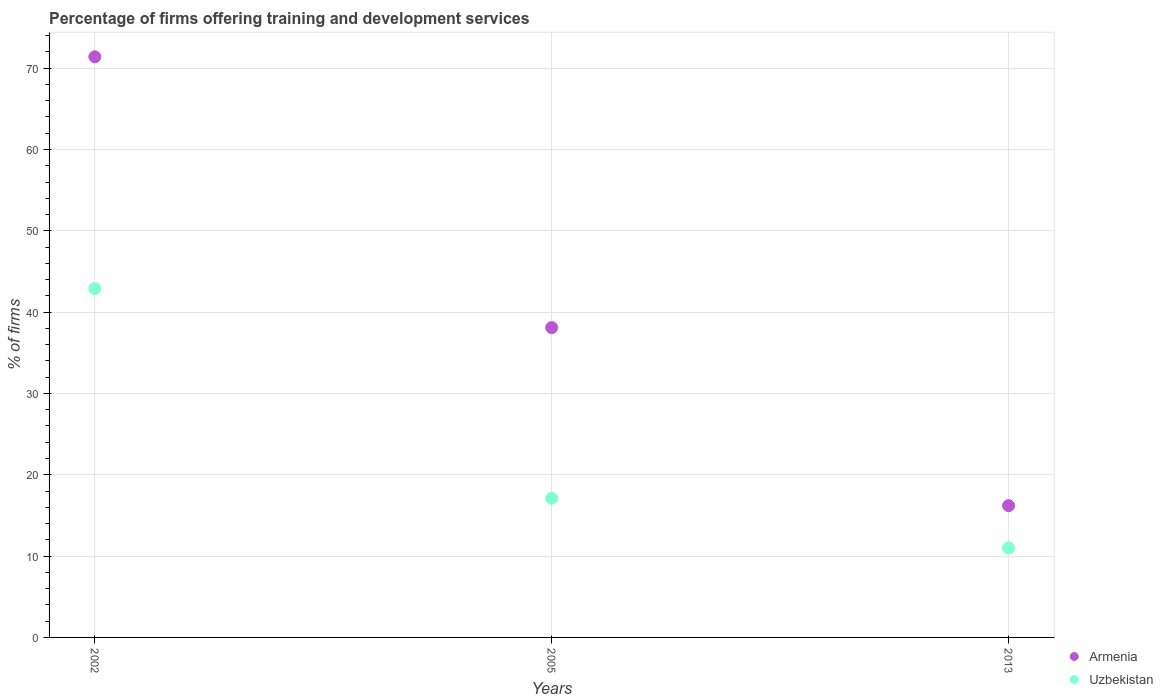How many different coloured dotlines are there?
Make the answer very short. 2. Is the number of dotlines equal to the number of legend labels?
Your answer should be very brief. Yes. What is the percentage of firms offering training and development in Armenia in 2005?
Give a very brief answer. 38.1. Across all years, what is the maximum percentage of firms offering training and development in Uzbekistan?
Make the answer very short. 42.9. Across all years, what is the minimum percentage of firms offering training and development in Uzbekistan?
Offer a very short reply. 11. In which year was the percentage of firms offering training and development in Uzbekistan minimum?
Make the answer very short. 2013. What is the total percentage of firms offering training and development in Armenia in the graph?
Provide a short and direct response. 125.7. What is the difference between the percentage of firms offering training and development in Armenia in 2002 and that in 2005?
Offer a terse response. 33.3. What is the difference between the percentage of firms offering training and development in Uzbekistan in 2002 and the percentage of firms offering training and development in Armenia in 2013?
Ensure brevity in your answer.  26.7. What is the average percentage of firms offering training and development in Uzbekistan per year?
Provide a succinct answer. 23.67. In the year 2005, what is the difference between the percentage of firms offering training and development in Armenia and percentage of firms offering training and development in Uzbekistan?
Make the answer very short. 21. In how many years, is the percentage of firms offering training and development in Armenia greater than 34 %?
Make the answer very short. 2. Is the percentage of firms offering training and development in Uzbekistan in 2002 less than that in 2005?
Your response must be concise. No. Is the difference between the percentage of firms offering training and development in Armenia in 2002 and 2013 greater than the difference between the percentage of firms offering training and development in Uzbekistan in 2002 and 2013?
Your answer should be very brief. Yes. What is the difference between the highest and the second highest percentage of firms offering training and development in Armenia?
Provide a short and direct response. 33.3. What is the difference between the highest and the lowest percentage of firms offering training and development in Armenia?
Give a very brief answer. 55.2. In how many years, is the percentage of firms offering training and development in Uzbekistan greater than the average percentage of firms offering training and development in Uzbekistan taken over all years?
Ensure brevity in your answer.  1. Does the percentage of firms offering training and development in Armenia monotonically increase over the years?
Offer a terse response. No. Is the percentage of firms offering training and development in Uzbekistan strictly less than the percentage of firms offering training and development in Armenia over the years?
Provide a succinct answer. Yes. How many dotlines are there?
Give a very brief answer. 2. What is the difference between two consecutive major ticks on the Y-axis?
Provide a succinct answer. 10. Are the values on the major ticks of Y-axis written in scientific E-notation?
Give a very brief answer. No. What is the title of the graph?
Your answer should be very brief. Percentage of firms offering training and development services. Does "El Salvador" appear as one of the legend labels in the graph?
Your response must be concise. No. What is the label or title of the X-axis?
Ensure brevity in your answer.  Years. What is the label or title of the Y-axis?
Ensure brevity in your answer.  % of firms. What is the % of firms in Armenia in 2002?
Your answer should be compact. 71.4. What is the % of firms in Uzbekistan in 2002?
Keep it short and to the point. 42.9. What is the % of firms in Armenia in 2005?
Provide a short and direct response. 38.1. What is the % of firms of Armenia in 2013?
Your answer should be very brief. 16.2. What is the % of firms of Uzbekistan in 2013?
Keep it short and to the point. 11. Across all years, what is the maximum % of firms of Armenia?
Your answer should be very brief. 71.4. Across all years, what is the maximum % of firms in Uzbekistan?
Ensure brevity in your answer.  42.9. Across all years, what is the minimum % of firms of Armenia?
Make the answer very short. 16.2. Across all years, what is the minimum % of firms in Uzbekistan?
Offer a terse response. 11. What is the total % of firms in Armenia in the graph?
Ensure brevity in your answer.  125.7. What is the difference between the % of firms in Armenia in 2002 and that in 2005?
Give a very brief answer. 33.3. What is the difference between the % of firms in Uzbekistan in 2002 and that in 2005?
Offer a terse response. 25.8. What is the difference between the % of firms of Armenia in 2002 and that in 2013?
Give a very brief answer. 55.2. What is the difference between the % of firms in Uzbekistan in 2002 and that in 2013?
Your answer should be compact. 31.9. What is the difference between the % of firms of Armenia in 2005 and that in 2013?
Provide a short and direct response. 21.9. What is the difference between the % of firms in Uzbekistan in 2005 and that in 2013?
Make the answer very short. 6.1. What is the difference between the % of firms of Armenia in 2002 and the % of firms of Uzbekistan in 2005?
Offer a terse response. 54.3. What is the difference between the % of firms of Armenia in 2002 and the % of firms of Uzbekistan in 2013?
Your answer should be compact. 60.4. What is the difference between the % of firms of Armenia in 2005 and the % of firms of Uzbekistan in 2013?
Your answer should be very brief. 27.1. What is the average % of firms of Armenia per year?
Your answer should be very brief. 41.9. What is the average % of firms in Uzbekistan per year?
Ensure brevity in your answer.  23.67. What is the ratio of the % of firms in Armenia in 2002 to that in 2005?
Provide a succinct answer. 1.87. What is the ratio of the % of firms in Uzbekistan in 2002 to that in 2005?
Provide a short and direct response. 2.51. What is the ratio of the % of firms of Armenia in 2002 to that in 2013?
Ensure brevity in your answer.  4.41. What is the ratio of the % of firms of Armenia in 2005 to that in 2013?
Ensure brevity in your answer.  2.35. What is the ratio of the % of firms of Uzbekistan in 2005 to that in 2013?
Offer a terse response. 1.55. What is the difference between the highest and the second highest % of firms in Armenia?
Your answer should be very brief. 33.3. What is the difference between the highest and the second highest % of firms of Uzbekistan?
Keep it short and to the point. 25.8. What is the difference between the highest and the lowest % of firms in Armenia?
Offer a terse response. 55.2. What is the difference between the highest and the lowest % of firms in Uzbekistan?
Provide a short and direct response. 31.9. 